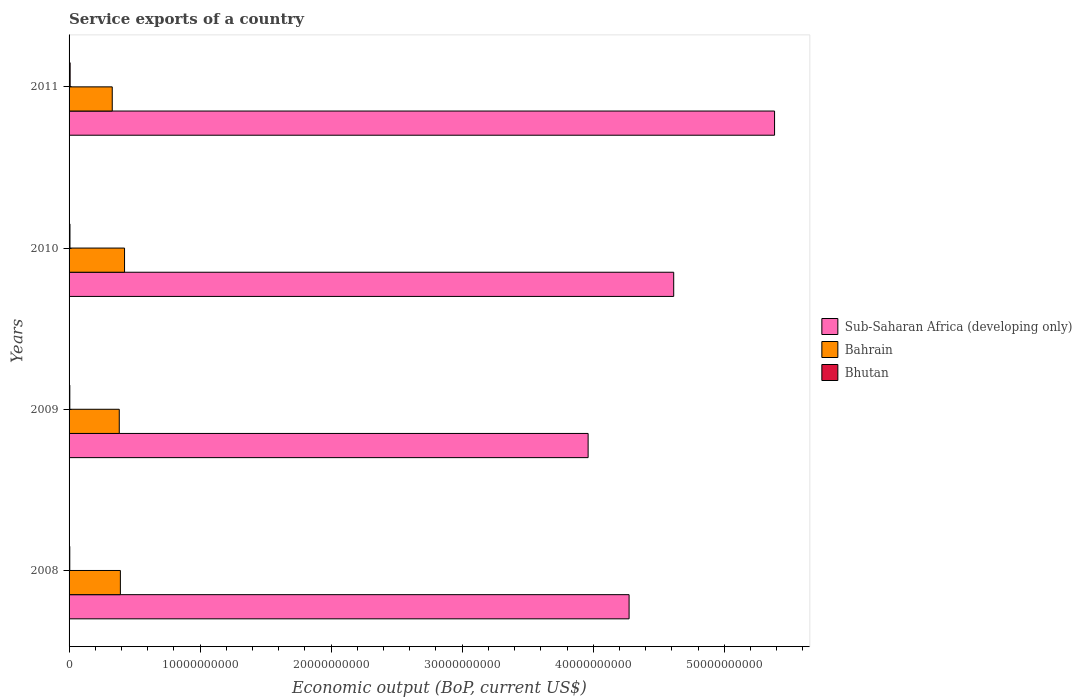Are the number of bars per tick equal to the number of legend labels?
Your answer should be compact. Yes. How many bars are there on the 3rd tick from the top?
Provide a short and direct response. 3. In how many cases, is the number of bars for a given year not equal to the number of legend labels?
Provide a short and direct response. 0. What is the service exports in Bahrain in 2008?
Give a very brief answer. 3.92e+09. Across all years, what is the maximum service exports in Bahrain?
Your answer should be compact. 4.23e+09. Across all years, what is the minimum service exports in Bahrain?
Make the answer very short. 3.30e+09. In which year was the service exports in Sub-Saharan Africa (developing only) minimum?
Your response must be concise. 2009. What is the total service exports in Bhutan in the graph?
Offer a terse response. 2.62e+08. What is the difference between the service exports in Bhutan in 2009 and that in 2010?
Keep it short and to the point. -1.25e+07. What is the difference between the service exports in Sub-Saharan Africa (developing only) in 2010 and the service exports in Bahrain in 2009?
Your answer should be very brief. 4.23e+1. What is the average service exports in Bhutan per year?
Offer a very short reply. 6.55e+07. In the year 2011, what is the difference between the service exports in Bhutan and service exports in Sub-Saharan Africa (developing only)?
Your response must be concise. -5.38e+1. In how many years, is the service exports in Sub-Saharan Africa (developing only) greater than 28000000000 US$?
Provide a succinct answer. 4. What is the ratio of the service exports in Sub-Saharan Africa (developing only) in 2008 to that in 2009?
Provide a succinct answer. 1.08. Is the service exports in Bhutan in 2008 less than that in 2010?
Offer a very short reply. Yes. What is the difference between the highest and the second highest service exports in Bhutan?
Make the answer very short. 1.31e+07. What is the difference between the highest and the lowest service exports in Sub-Saharan Africa (developing only)?
Make the answer very short. 1.42e+1. Is the sum of the service exports in Bahrain in 2009 and 2011 greater than the maximum service exports in Sub-Saharan Africa (developing only) across all years?
Keep it short and to the point. No. What does the 3rd bar from the top in 2009 represents?
Ensure brevity in your answer.  Sub-Saharan Africa (developing only). What does the 3rd bar from the bottom in 2011 represents?
Give a very brief answer. Bhutan. Is it the case that in every year, the sum of the service exports in Bhutan and service exports in Bahrain is greater than the service exports in Sub-Saharan Africa (developing only)?
Your answer should be very brief. No. Are all the bars in the graph horizontal?
Give a very brief answer. Yes. How many years are there in the graph?
Ensure brevity in your answer.  4. What is the difference between two consecutive major ticks on the X-axis?
Offer a terse response. 1.00e+1. Are the values on the major ticks of X-axis written in scientific E-notation?
Make the answer very short. No. Does the graph contain any zero values?
Offer a very short reply. No. Does the graph contain grids?
Keep it short and to the point. No. Where does the legend appear in the graph?
Offer a terse response. Center right. How are the legend labels stacked?
Provide a succinct answer. Vertical. What is the title of the graph?
Offer a terse response. Service exports of a country. What is the label or title of the X-axis?
Offer a terse response. Economic output (BoP, current US$). What is the label or title of the Y-axis?
Your answer should be compact. Years. What is the Economic output (BoP, current US$) of Sub-Saharan Africa (developing only) in 2008?
Your response must be concise. 4.27e+1. What is the Economic output (BoP, current US$) in Bahrain in 2008?
Provide a succinct answer. 3.92e+09. What is the Economic output (BoP, current US$) of Bhutan in 2008?
Ensure brevity in your answer.  5.48e+07. What is the Economic output (BoP, current US$) of Sub-Saharan Africa (developing only) in 2009?
Keep it short and to the point. 3.96e+1. What is the Economic output (BoP, current US$) in Bahrain in 2009?
Provide a succinct answer. 3.83e+09. What is the Economic output (BoP, current US$) of Bhutan in 2009?
Keep it short and to the point. 5.63e+07. What is the Economic output (BoP, current US$) of Sub-Saharan Africa (developing only) in 2010?
Your response must be concise. 4.61e+1. What is the Economic output (BoP, current US$) in Bahrain in 2010?
Ensure brevity in your answer.  4.23e+09. What is the Economic output (BoP, current US$) of Bhutan in 2010?
Ensure brevity in your answer.  6.88e+07. What is the Economic output (BoP, current US$) of Sub-Saharan Africa (developing only) in 2011?
Your answer should be very brief. 5.38e+1. What is the Economic output (BoP, current US$) in Bahrain in 2011?
Keep it short and to the point. 3.30e+09. What is the Economic output (BoP, current US$) in Bhutan in 2011?
Offer a terse response. 8.19e+07. Across all years, what is the maximum Economic output (BoP, current US$) in Sub-Saharan Africa (developing only)?
Offer a very short reply. 5.38e+1. Across all years, what is the maximum Economic output (BoP, current US$) in Bahrain?
Make the answer very short. 4.23e+09. Across all years, what is the maximum Economic output (BoP, current US$) of Bhutan?
Provide a short and direct response. 8.19e+07. Across all years, what is the minimum Economic output (BoP, current US$) of Sub-Saharan Africa (developing only)?
Your answer should be very brief. 3.96e+1. Across all years, what is the minimum Economic output (BoP, current US$) in Bahrain?
Your answer should be compact. 3.30e+09. Across all years, what is the minimum Economic output (BoP, current US$) in Bhutan?
Ensure brevity in your answer.  5.48e+07. What is the total Economic output (BoP, current US$) of Sub-Saharan Africa (developing only) in the graph?
Ensure brevity in your answer.  1.82e+11. What is the total Economic output (BoP, current US$) of Bahrain in the graph?
Your response must be concise. 1.53e+1. What is the total Economic output (BoP, current US$) of Bhutan in the graph?
Your answer should be very brief. 2.62e+08. What is the difference between the Economic output (BoP, current US$) of Sub-Saharan Africa (developing only) in 2008 and that in 2009?
Provide a succinct answer. 3.13e+09. What is the difference between the Economic output (BoP, current US$) in Bahrain in 2008 and that in 2009?
Your answer should be very brief. 8.46e+07. What is the difference between the Economic output (BoP, current US$) in Bhutan in 2008 and that in 2009?
Provide a succinct answer. -1.55e+06. What is the difference between the Economic output (BoP, current US$) in Sub-Saharan Africa (developing only) in 2008 and that in 2010?
Your answer should be compact. -3.40e+09. What is the difference between the Economic output (BoP, current US$) of Bahrain in 2008 and that in 2010?
Offer a very short reply. -3.18e+08. What is the difference between the Economic output (BoP, current US$) in Bhutan in 2008 and that in 2010?
Make the answer very short. -1.41e+07. What is the difference between the Economic output (BoP, current US$) of Sub-Saharan Africa (developing only) in 2008 and that in 2011?
Offer a terse response. -1.11e+1. What is the difference between the Economic output (BoP, current US$) of Bahrain in 2008 and that in 2011?
Your response must be concise. 6.20e+08. What is the difference between the Economic output (BoP, current US$) of Bhutan in 2008 and that in 2011?
Your response must be concise. -2.71e+07. What is the difference between the Economic output (BoP, current US$) in Sub-Saharan Africa (developing only) in 2009 and that in 2010?
Give a very brief answer. -6.53e+09. What is the difference between the Economic output (BoP, current US$) in Bahrain in 2009 and that in 2010?
Make the answer very short. -4.02e+08. What is the difference between the Economic output (BoP, current US$) in Bhutan in 2009 and that in 2010?
Offer a very short reply. -1.25e+07. What is the difference between the Economic output (BoP, current US$) of Sub-Saharan Africa (developing only) in 2009 and that in 2011?
Provide a short and direct response. -1.42e+1. What is the difference between the Economic output (BoP, current US$) in Bahrain in 2009 and that in 2011?
Provide a short and direct response. 5.35e+08. What is the difference between the Economic output (BoP, current US$) of Bhutan in 2009 and that in 2011?
Your answer should be very brief. -2.56e+07. What is the difference between the Economic output (BoP, current US$) of Sub-Saharan Africa (developing only) in 2010 and that in 2011?
Make the answer very short. -7.70e+09. What is the difference between the Economic output (BoP, current US$) in Bahrain in 2010 and that in 2011?
Offer a terse response. 9.38e+08. What is the difference between the Economic output (BoP, current US$) in Bhutan in 2010 and that in 2011?
Your answer should be compact. -1.31e+07. What is the difference between the Economic output (BoP, current US$) in Sub-Saharan Africa (developing only) in 2008 and the Economic output (BoP, current US$) in Bahrain in 2009?
Offer a very short reply. 3.89e+1. What is the difference between the Economic output (BoP, current US$) of Sub-Saharan Africa (developing only) in 2008 and the Economic output (BoP, current US$) of Bhutan in 2009?
Ensure brevity in your answer.  4.27e+1. What is the difference between the Economic output (BoP, current US$) of Bahrain in 2008 and the Economic output (BoP, current US$) of Bhutan in 2009?
Keep it short and to the point. 3.86e+09. What is the difference between the Economic output (BoP, current US$) in Sub-Saharan Africa (developing only) in 2008 and the Economic output (BoP, current US$) in Bahrain in 2010?
Keep it short and to the point. 3.85e+1. What is the difference between the Economic output (BoP, current US$) of Sub-Saharan Africa (developing only) in 2008 and the Economic output (BoP, current US$) of Bhutan in 2010?
Your answer should be very brief. 4.27e+1. What is the difference between the Economic output (BoP, current US$) in Bahrain in 2008 and the Economic output (BoP, current US$) in Bhutan in 2010?
Your answer should be very brief. 3.85e+09. What is the difference between the Economic output (BoP, current US$) in Sub-Saharan Africa (developing only) in 2008 and the Economic output (BoP, current US$) in Bahrain in 2011?
Ensure brevity in your answer.  3.94e+1. What is the difference between the Economic output (BoP, current US$) of Sub-Saharan Africa (developing only) in 2008 and the Economic output (BoP, current US$) of Bhutan in 2011?
Keep it short and to the point. 4.27e+1. What is the difference between the Economic output (BoP, current US$) in Bahrain in 2008 and the Economic output (BoP, current US$) in Bhutan in 2011?
Offer a very short reply. 3.83e+09. What is the difference between the Economic output (BoP, current US$) in Sub-Saharan Africa (developing only) in 2009 and the Economic output (BoP, current US$) in Bahrain in 2010?
Your answer should be very brief. 3.54e+1. What is the difference between the Economic output (BoP, current US$) of Sub-Saharan Africa (developing only) in 2009 and the Economic output (BoP, current US$) of Bhutan in 2010?
Your response must be concise. 3.95e+1. What is the difference between the Economic output (BoP, current US$) of Bahrain in 2009 and the Economic output (BoP, current US$) of Bhutan in 2010?
Keep it short and to the point. 3.76e+09. What is the difference between the Economic output (BoP, current US$) of Sub-Saharan Africa (developing only) in 2009 and the Economic output (BoP, current US$) of Bahrain in 2011?
Provide a succinct answer. 3.63e+1. What is the difference between the Economic output (BoP, current US$) of Sub-Saharan Africa (developing only) in 2009 and the Economic output (BoP, current US$) of Bhutan in 2011?
Provide a succinct answer. 3.95e+1. What is the difference between the Economic output (BoP, current US$) of Bahrain in 2009 and the Economic output (BoP, current US$) of Bhutan in 2011?
Your answer should be very brief. 3.75e+09. What is the difference between the Economic output (BoP, current US$) in Sub-Saharan Africa (developing only) in 2010 and the Economic output (BoP, current US$) in Bahrain in 2011?
Give a very brief answer. 4.28e+1. What is the difference between the Economic output (BoP, current US$) of Sub-Saharan Africa (developing only) in 2010 and the Economic output (BoP, current US$) of Bhutan in 2011?
Give a very brief answer. 4.61e+1. What is the difference between the Economic output (BoP, current US$) in Bahrain in 2010 and the Economic output (BoP, current US$) in Bhutan in 2011?
Give a very brief answer. 4.15e+09. What is the average Economic output (BoP, current US$) of Sub-Saharan Africa (developing only) per year?
Provide a succinct answer. 4.56e+1. What is the average Economic output (BoP, current US$) in Bahrain per year?
Make the answer very short. 3.82e+09. What is the average Economic output (BoP, current US$) of Bhutan per year?
Ensure brevity in your answer.  6.55e+07. In the year 2008, what is the difference between the Economic output (BoP, current US$) in Sub-Saharan Africa (developing only) and Economic output (BoP, current US$) in Bahrain?
Your response must be concise. 3.88e+1. In the year 2008, what is the difference between the Economic output (BoP, current US$) of Sub-Saharan Africa (developing only) and Economic output (BoP, current US$) of Bhutan?
Offer a very short reply. 4.27e+1. In the year 2008, what is the difference between the Economic output (BoP, current US$) in Bahrain and Economic output (BoP, current US$) in Bhutan?
Make the answer very short. 3.86e+09. In the year 2009, what is the difference between the Economic output (BoP, current US$) of Sub-Saharan Africa (developing only) and Economic output (BoP, current US$) of Bahrain?
Provide a succinct answer. 3.58e+1. In the year 2009, what is the difference between the Economic output (BoP, current US$) in Sub-Saharan Africa (developing only) and Economic output (BoP, current US$) in Bhutan?
Provide a succinct answer. 3.96e+1. In the year 2009, what is the difference between the Economic output (BoP, current US$) in Bahrain and Economic output (BoP, current US$) in Bhutan?
Keep it short and to the point. 3.77e+09. In the year 2010, what is the difference between the Economic output (BoP, current US$) of Sub-Saharan Africa (developing only) and Economic output (BoP, current US$) of Bahrain?
Your response must be concise. 4.19e+1. In the year 2010, what is the difference between the Economic output (BoP, current US$) in Sub-Saharan Africa (developing only) and Economic output (BoP, current US$) in Bhutan?
Your answer should be compact. 4.61e+1. In the year 2010, what is the difference between the Economic output (BoP, current US$) in Bahrain and Economic output (BoP, current US$) in Bhutan?
Your answer should be compact. 4.16e+09. In the year 2011, what is the difference between the Economic output (BoP, current US$) in Sub-Saharan Africa (developing only) and Economic output (BoP, current US$) in Bahrain?
Your answer should be compact. 5.05e+1. In the year 2011, what is the difference between the Economic output (BoP, current US$) in Sub-Saharan Africa (developing only) and Economic output (BoP, current US$) in Bhutan?
Your answer should be very brief. 5.38e+1. In the year 2011, what is the difference between the Economic output (BoP, current US$) of Bahrain and Economic output (BoP, current US$) of Bhutan?
Your answer should be very brief. 3.21e+09. What is the ratio of the Economic output (BoP, current US$) in Sub-Saharan Africa (developing only) in 2008 to that in 2009?
Keep it short and to the point. 1.08. What is the ratio of the Economic output (BoP, current US$) of Bahrain in 2008 to that in 2009?
Provide a succinct answer. 1.02. What is the ratio of the Economic output (BoP, current US$) in Bhutan in 2008 to that in 2009?
Offer a very short reply. 0.97. What is the ratio of the Economic output (BoP, current US$) of Sub-Saharan Africa (developing only) in 2008 to that in 2010?
Keep it short and to the point. 0.93. What is the ratio of the Economic output (BoP, current US$) in Bahrain in 2008 to that in 2010?
Your answer should be very brief. 0.93. What is the ratio of the Economic output (BoP, current US$) in Bhutan in 2008 to that in 2010?
Keep it short and to the point. 0.8. What is the ratio of the Economic output (BoP, current US$) in Sub-Saharan Africa (developing only) in 2008 to that in 2011?
Your answer should be compact. 0.79. What is the ratio of the Economic output (BoP, current US$) in Bahrain in 2008 to that in 2011?
Offer a very short reply. 1.19. What is the ratio of the Economic output (BoP, current US$) of Bhutan in 2008 to that in 2011?
Offer a terse response. 0.67. What is the ratio of the Economic output (BoP, current US$) in Sub-Saharan Africa (developing only) in 2009 to that in 2010?
Your answer should be very brief. 0.86. What is the ratio of the Economic output (BoP, current US$) in Bahrain in 2009 to that in 2010?
Your response must be concise. 0.91. What is the ratio of the Economic output (BoP, current US$) in Bhutan in 2009 to that in 2010?
Keep it short and to the point. 0.82. What is the ratio of the Economic output (BoP, current US$) in Sub-Saharan Africa (developing only) in 2009 to that in 2011?
Your answer should be very brief. 0.74. What is the ratio of the Economic output (BoP, current US$) in Bahrain in 2009 to that in 2011?
Keep it short and to the point. 1.16. What is the ratio of the Economic output (BoP, current US$) in Bhutan in 2009 to that in 2011?
Your answer should be very brief. 0.69. What is the ratio of the Economic output (BoP, current US$) in Sub-Saharan Africa (developing only) in 2010 to that in 2011?
Provide a succinct answer. 0.86. What is the ratio of the Economic output (BoP, current US$) in Bahrain in 2010 to that in 2011?
Ensure brevity in your answer.  1.28. What is the ratio of the Economic output (BoP, current US$) of Bhutan in 2010 to that in 2011?
Offer a terse response. 0.84. What is the difference between the highest and the second highest Economic output (BoP, current US$) in Sub-Saharan Africa (developing only)?
Your answer should be compact. 7.70e+09. What is the difference between the highest and the second highest Economic output (BoP, current US$) of Bahrain?
Your response must be concise. 3.18e+08. What is the difference between the highest and the second highest Economic output (BoP, current US$) in Bhutan?
Give a very brief answer. 1.31e+07. What is the difference between the highest and the lowest Economic output (BoP, current US$) of Sub-Saharan Africa (developing only)?
Your response must be concise. 1.42e+1. What is the difference between the highest and the lowest Economic output (BoP, current US$) of Bahrain?
Provide a short and direct response. 9.38e+08. What is the difference between the highest and the lowest Economic output (BoP, current US$) in Bhutan?
Provide a short and direct response. 2.71e+07. 